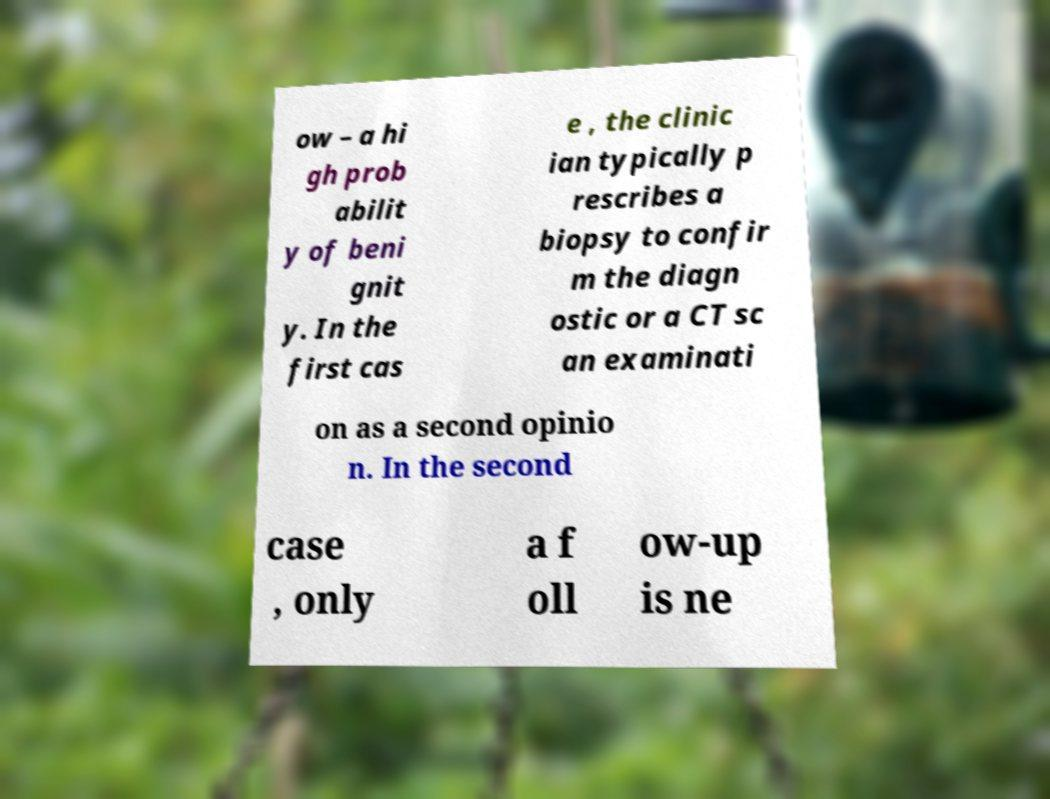Could you extract and type out the text from this image? ow – a hi gh prob abilit y of beni gnit y. In the first cas e , the clinic ian typically p rescribes a biopsy to confir m the diagn ostic or a CT sc an examinati on as a second opinio n. In the second case , only a f oll ow-up is ne 